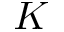Convert formula to latex. <formula><loc_0><loc_0><loc_500><loc_500>K</formula> 